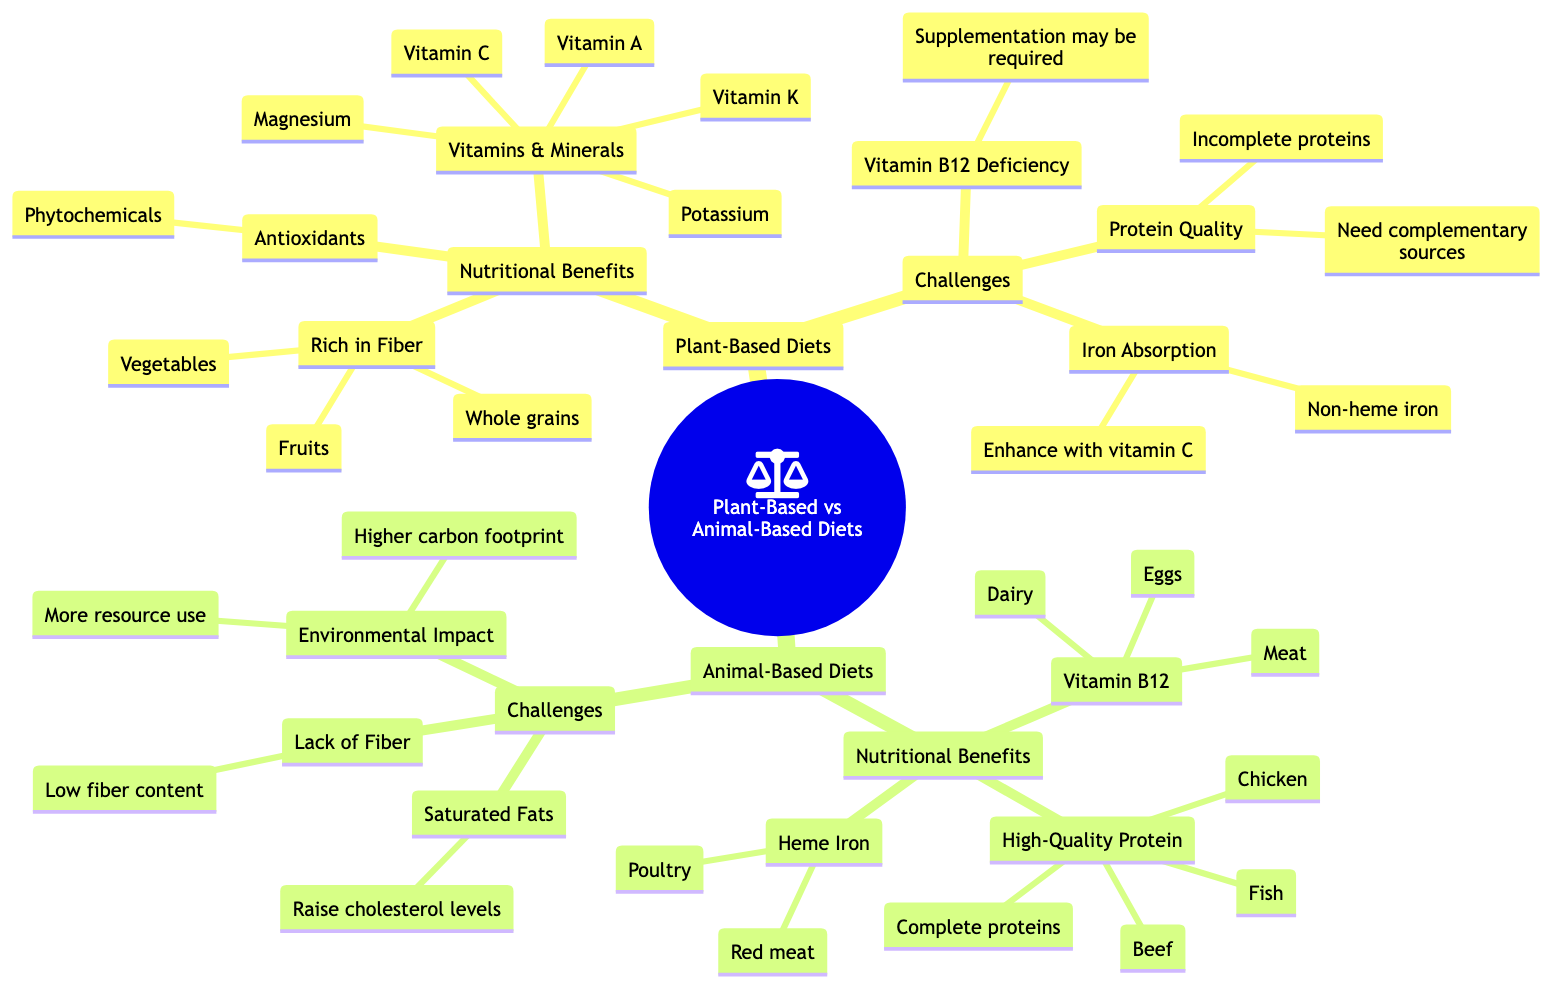What are the three nutritional benefits of Plant-Based Diets? The diagram lists the nutritional benefits under "Plant-Based Diets." It states three specific benefits: 'Rich in Fiber,' 'Vitamins & Minerals,' and 'Antioxidants.'
Answer: Rich in Fiber, Vitamins & Minerals, Antioxidants How many challenges are listed for Animal-Based Diets? The diagram outlines the 'Challenges' for 'Animal-Based Diets,' which includes three specific challenges: 'Saturated Fats,' 'Lack of Fiber,' and 'Environmental Impact.' Count these challenges for the answer.
Answer: 3 What type of iron is easier to absorb from Animal-Based Diets? According to the diagram, 'Heme Iron' is mentioned as the type of iron that is easier to absorb from sources such as red meat and poultry.
Answer: Heme Iron Which nutrients mentioned under Plant-Based Diets may require supplementation? The diagram specifically states that 'Vitamin B12 Deficiency' may require 'Supplementation' as it is difficult to obtain enough from plant sources.
Answer: Supplementation What is a nutritional benefit of Animal-Based Diets related to protein? The diagram refers to 'High-Quality Protein' under the 'Nutritional Benefits' of 'Animal-Based Diets,' indicating that it provides complete proteins from animal sources.
Answer: High-Quality Protein How does the diagram indicate the environmental impact of Animal-Based Diets? The diagram states that one of the challenges of 'Animal-Based Diets' is their 'Environmental Impact,' further mentioning that they have a higher carbon footprint and more resource use. This shows that animal-based diets have a negative environmental aspect.
Answer: Higher carbon footprint What are two complementary sources needed for Plant-Based diets' protein quality? The diagram indicates that the 'Challenges' of 'Plant-Based Diets' mention 'Complementary sources' as necessary due to 'Incomplete proteins.' Sources like beans and rice are commonly known supplements.
Answer: Beans and Rice What vitamins are specifically highlighted under Vitamins & Minerals for Plant-Based Diets? The diagram clearly lists 'Vitamin A,' 'Vitamin C,' 'Vitamin K,' and also mentions 'Potassium' and 'Magnesium' under the 'Vitamins & Minerals' of 'Plant-Based Diets.'
Answer: Vitamin A, Vitamin C, Vitamin K, Potassium, Magnesium 